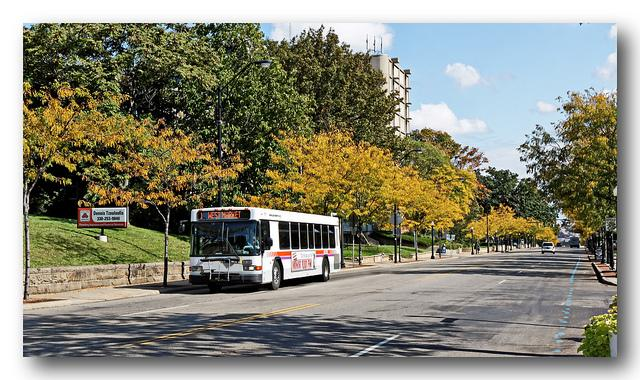What color is the line on the floor that is all the way to the right?

Choices:
A) blue
B) purple
C) orange
D) black blue 